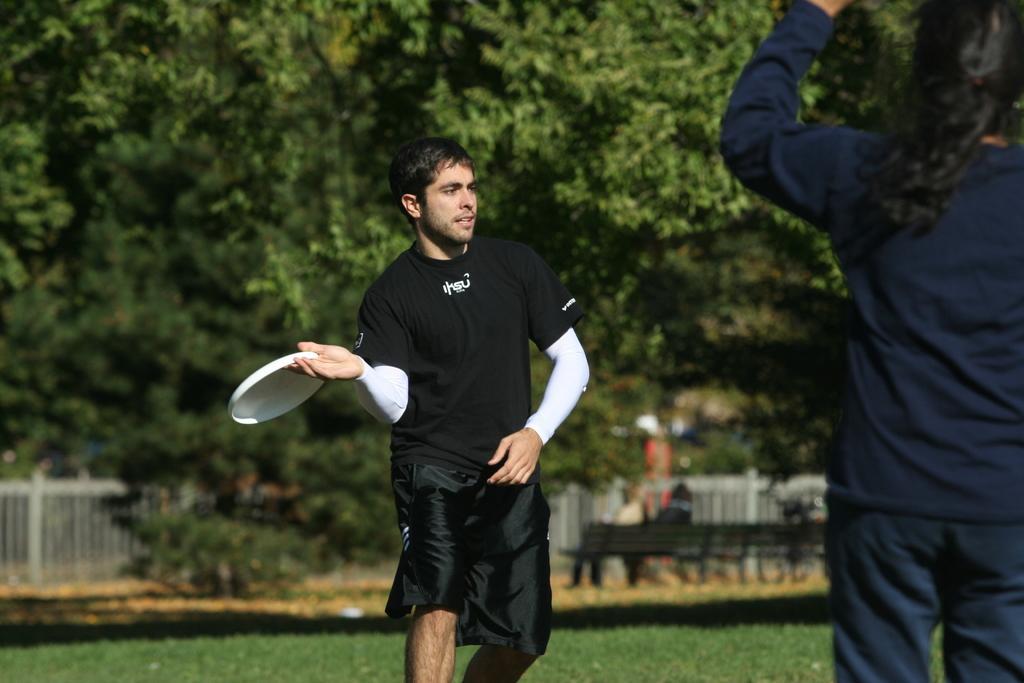Can you describe this image briefly? This image consists of a man playing with a disc. He is wearing a black T-shirt. On the right, there is a woman standing. In the background, there are many trees. At the bottom, there is green grass. And we can see the benches and few people in the background. On the left, there is a fencing. 